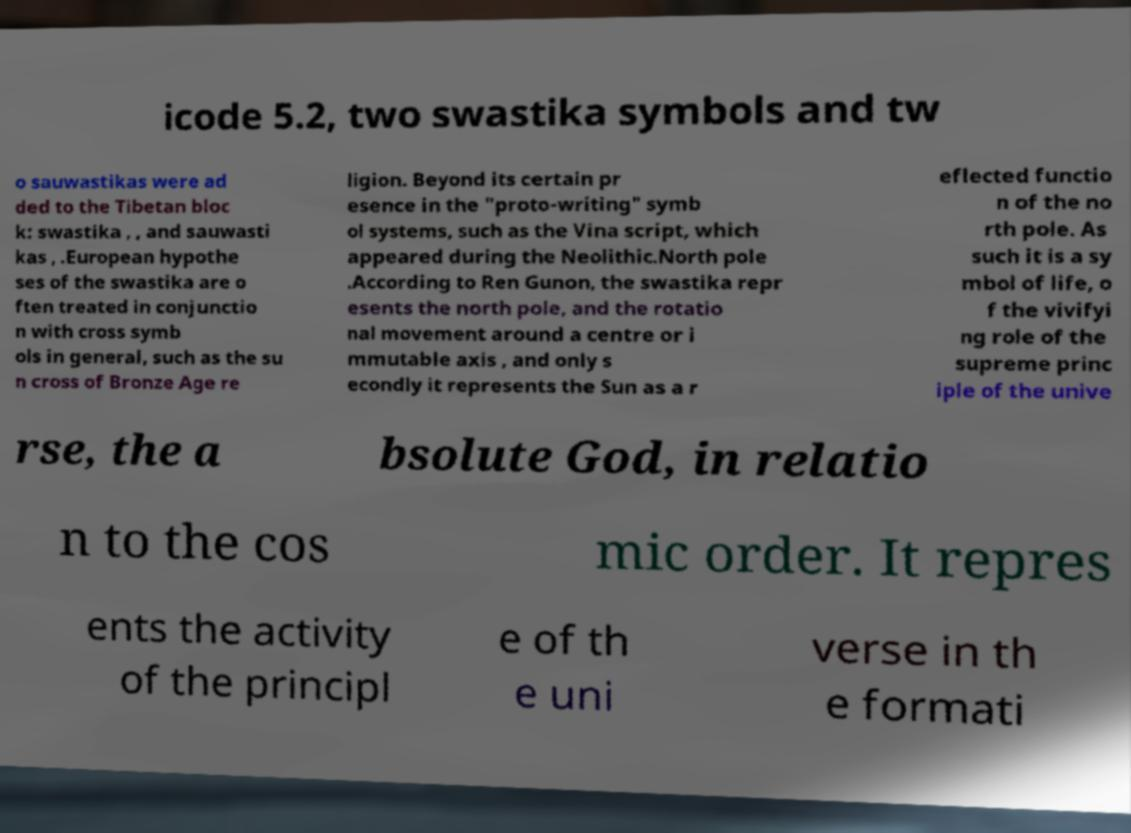There's text embedded in this image that I need extracted. Can you transcribe it verbatim? icode 5.2, two swastika symbols and tw o sauwastikas were ad ded to the Tibetan bloc k: swastika , , and sauwasti kas , .European hypothe ses of the swastika are o ften treated in conjunctio n with cross symb ols in general, such as the su n cross of Bronze Age re ligion. Beyond its certain pr esence in the "proto-writing" symb ol systems, such as the Vina script, which appeared during the Neolithic.North pole .According to Ren Gunon, the swastika repr esents the north pole, and the rotatio nal movement around a centre or i mmutable axis , and only s econdly it represents the Sun as a r eflected functio n of the no rth pole. As such it is a sy mbol of life, o f the vivifyi ng role of the supreme princ iple of the unive rse, the a bsolute God, in relatio n to the cos mic order. It repres ents the activity of the principl e of th e uni verse in th e formati 